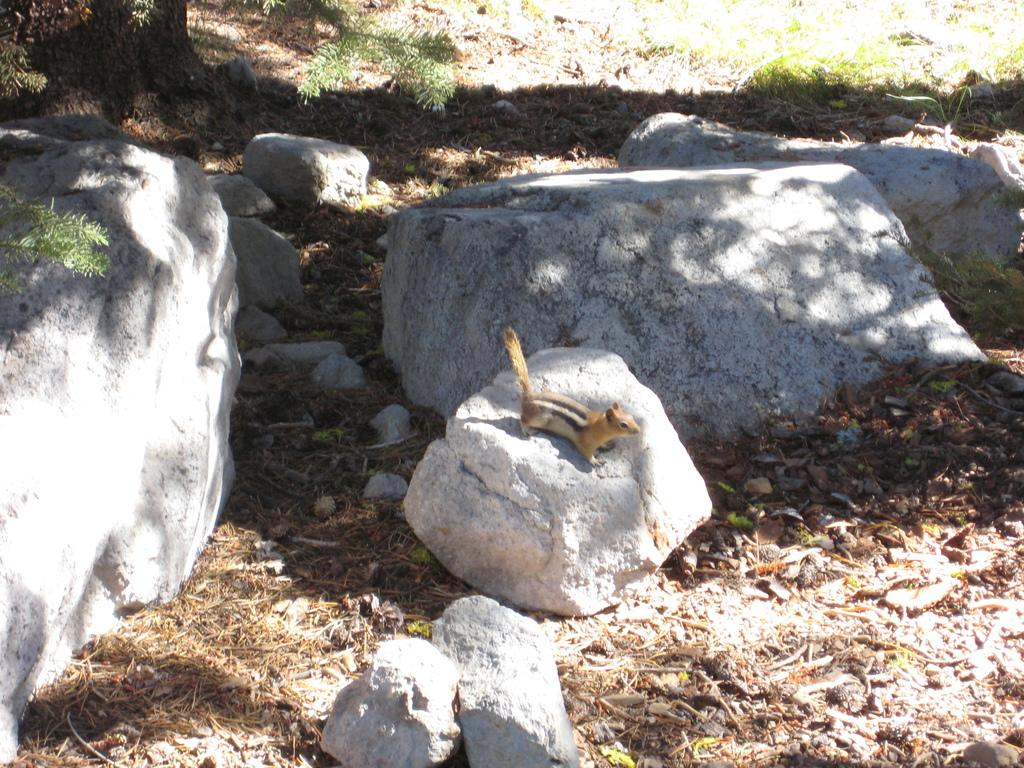What type of surface is visible in the image? There is a surface with rocks in the image. Is there any wildlife present on the rocks? Yes, a squirrel is present on one of the rocks. What type of vegetation can be seen behind the rock with the squirrel? There is grass visible behind the rock with the squirrel. What type of throne is the squirrel sitting on in the image? There is no throne present in the image; the squirrel is sitting on a rock. 